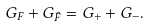<formula> <loc_0><loc_0><loc_500><loc_500>G _ { F } + G _ { \bar { F } } = G _ { + } + G _ { - } .</formula> 